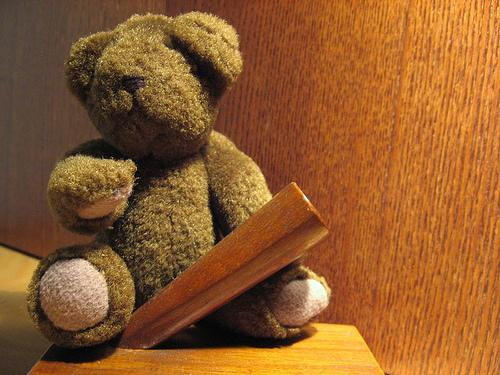Select an object associated with the teddy bear and its position, and compose a question asking about that object's color. Answer: Pink. Identify the primary object in the image and provide a short description of it. The primary object in the image is a teddy bear sitting on a wooden stand with its paws, feet, ears, nose, and mouth clearly visible. What object could be the focus of a product advertisement in the image? A soft and cuddly teddy bear with brown fur, round white feet, and a dark brown nose could be the focus of a product advertisement. Using visual cues, provide a brief summary of the main subject(s) in the picture. The image features a brown teddy bear with fluffy fur, dark brown nose, two distinct ears, white feet, and an expressive mouth, sitting on a wooden stand. Identify the primary subject within the image and narrate an advertising slogan for it. A cuddly teddy bear is the primary subject; slogan: "Discover endless hugs and love with our super-cute and irresistibly soft teddy bear – buy one today!" 